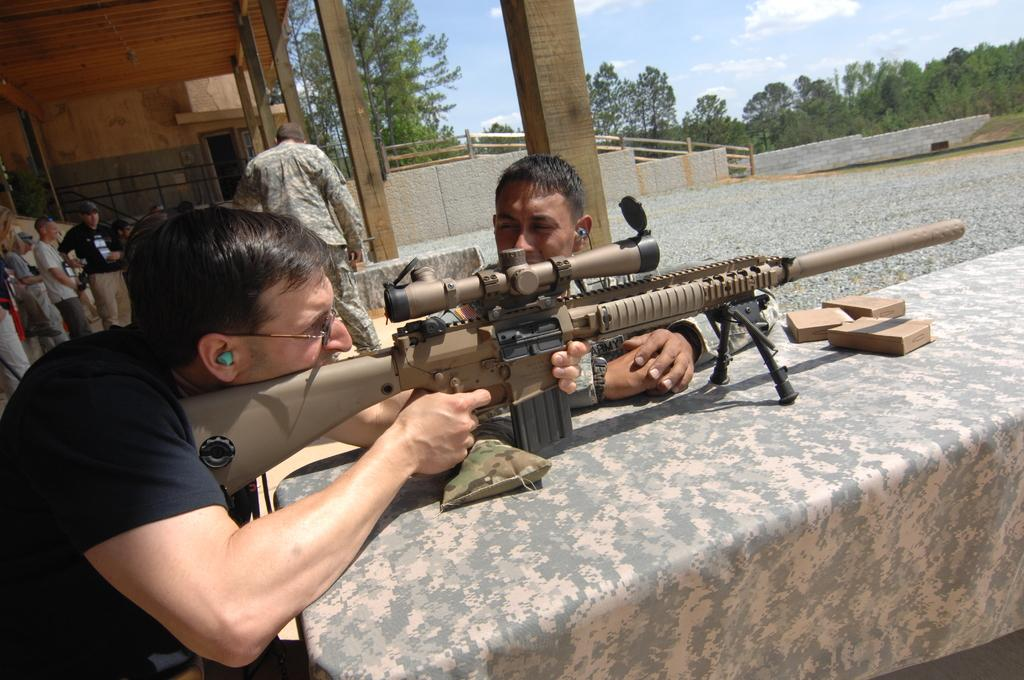What is the person in the image holding? The person is holding a gun in the image. How is the person holding the gun? The person is holding the gun while standing on a table. What can be seen in the background of the image? In the background of the image, there are persons, stairs, a wall, fencing, pillars, trees, and the sky. What is the condition of the sky in the image? The sky is visible in the background of the image, and there are clouds present. What type of goat can be seen climbing the pillars in the image? There is no goat present in the image, and therefore no such activity can be observed. What type of powder is being used to control the clouds in the image? There is no indication in the image that any powder is being used to control the clouds, and clouds are a natural weather phenomenon. 